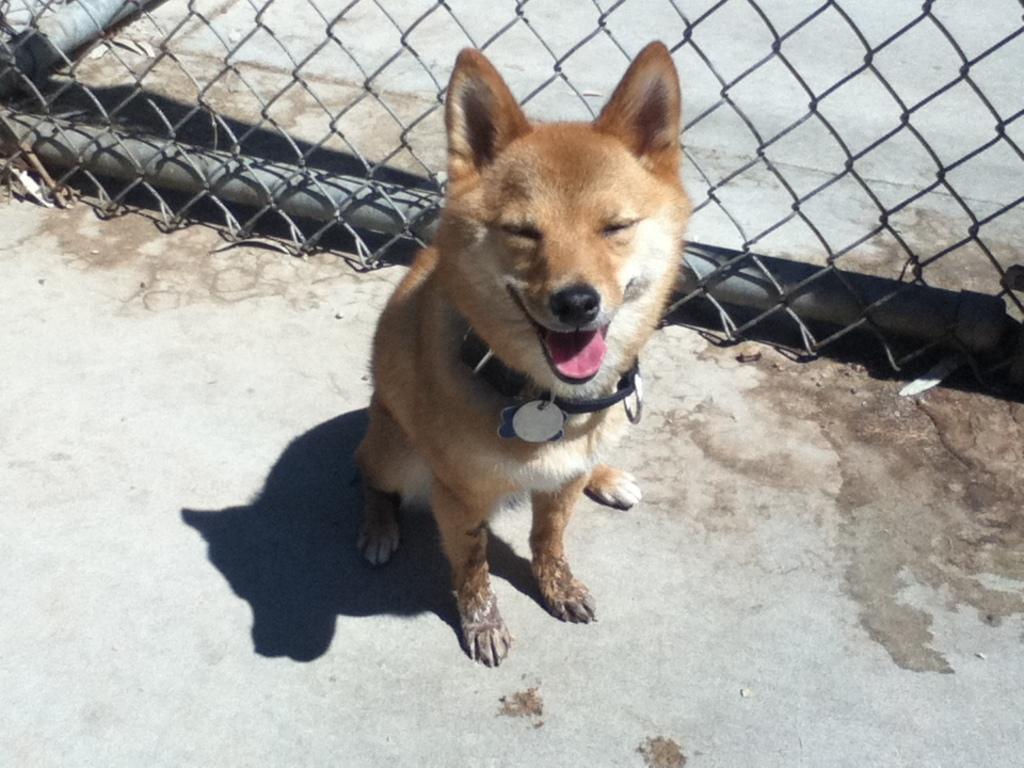How would you summarize this image in a sentence or two? In the foreground of this image, there is a dog sitting on the road. In the background, there is fencing. 